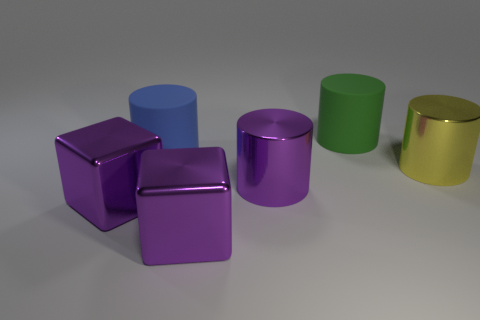Do the blue cylinder and the green matte cylinder have the same size?
Provide a succinct answer. Yes. How many other things are the same shape as the big green matte object?
Your answer should be very brief. 3. The object on the left side of the rubber thing that is to the left of the metal cylinder that is to the left of the green object is what shape?
Your answer should be compact. Cube. How many cylinders are either large yellow things or small rubber objects?
Offer a very short reply. 1. Is there a large green matte cylinder in front of the big thing right of the large green rubber object?
Your response must be concise. No. Are there any other things that have the same material as the large blue thing?
Your answer should be compact. Yes. There is a large green matte thing; does it have the same shape as the purple metallic thing on the left side of the blue cylinder?
Make the answer very short. No. How many other things are the same size as the green object?
Ensure brevity in your answer.  5. How many yellow objects are matte objects or metallic things?
Make the answer very short. 1. What number of large cylinders are both behind the purple shiny cylinder and in front of the large green thing?
Keep it short and to the point. 2. 